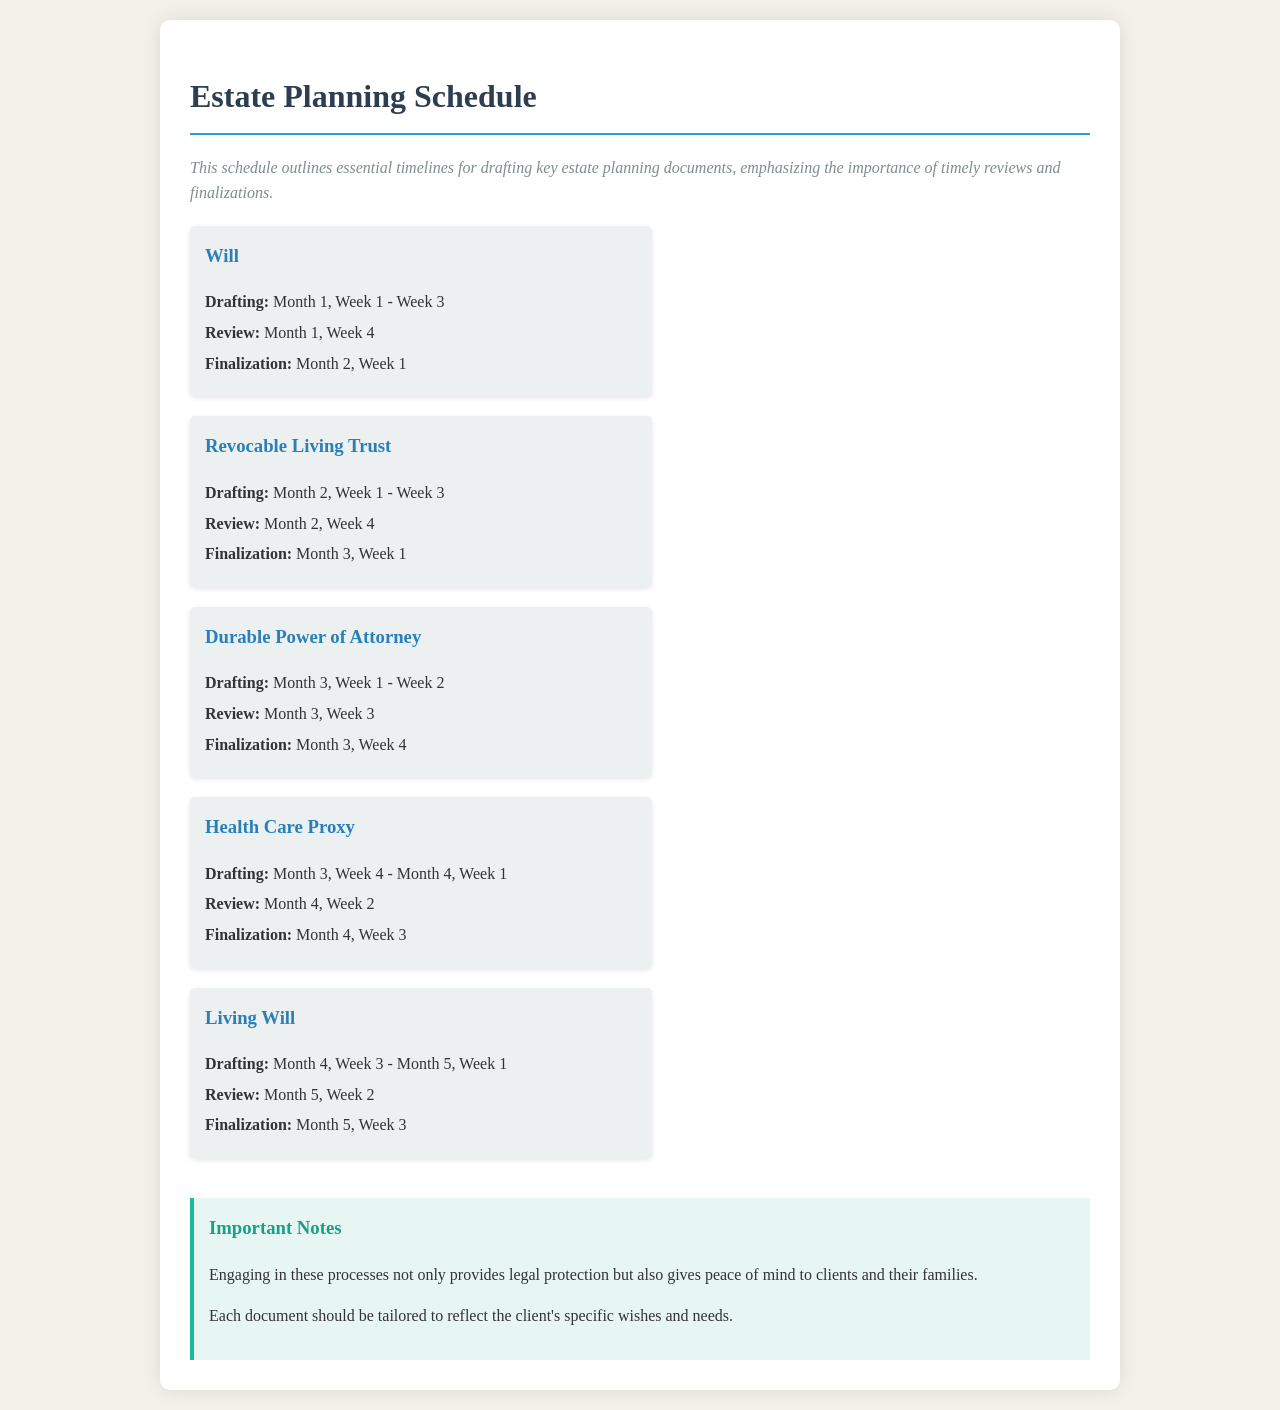What is the first document to be drafted? The first document listed is the Will, which is the starting point in the estate planning schedule.
Answer: Will When is the review for the Durable Power of Attorney? The review date is specified as Month 3, Week 3 for this document.
Answer: Month 3, Week 3 What is the finalization date for the Health Care Proxy? The finalization date is specified in the document for the Health Care Proxy as Month 4, Week 3.
Answer: Month 4, Week 3 How long is the drafting period for the Revocable Living Trust? The drafting period for this document runs from Month 2, Week 1 to Week 3, indicating a three-week duration.
Answer: 3 weeks What type of document follows the Living Will? The documents are presented in a sequence, and after the Living Will, there are no additional documents listed, indicating it is the last one in this schedule.
Answer: None Describe the importance mentioned in the notes section. The notes emphasize that these processes provide legal protection and peace of mind to clients and their families.
Answer: Legal protection and peace of mind What week does the drafting of the Living Will start? The drafting of the Living Will begins in Month 4, Week 3, clearly stated in the document timeline.
Answer: Month 4, Week 3 When does the finalization of the Will occur? The finalization schedule indicates that the Will will be finalized in Month 2, Week 1.
Answer: Month 2, Week 1 